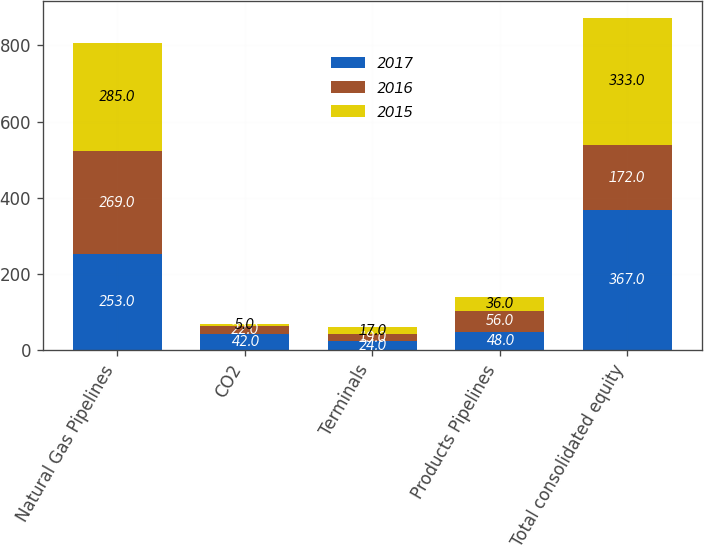<chart> <loc_0><loc_0><loc_500><loc_500><stacked_bar_chart><ecel><fcel>Natural Gas Pipelines<fcel>CO2<fcel>Terminals<fcel>Products Pipelines<fcel>Total consolidated equity<nl><fcel>2017<fcel>253<fcel>42<fcel>24<fcel>48<fcel>367<nl><fcel>2016<fcel>269<fcel>22<fcel>19<fcel>56<fcel>172<nl><fcel>2015<fcel>285<fcel>5<fcel>17<fcel>36<fcel>333<nl></chart> 